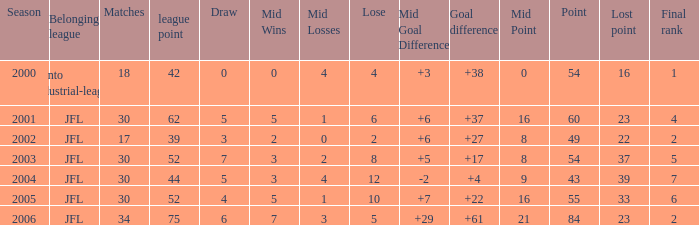Parse the full table. {'header': ['Season', 'Belonging league', 'Matches', 'league point', 'Draw', 'Mid Wins', 'Mid Losses', 'Lose', 'Mid Goal Difference', 'Goal difference', 'Mid Point', 'Point', 'Lost point', 'Final rank'], 'rows': [['2000', 'Kanto industrial-league', '18', '42', '0', '0', '4', '4', '+3', '+38', '0', '54', '16', '1'], ['2001', 'JFL', '30', '62', '5', '5', '1', '6', '+6', '+37', '16', '60', '23', '4'], ['2002', 'JFL', '17', '39', '3', '2', '0', '2', '+6', '+27', '8', '49', '22', '2'], ['2003', 'JFL', '30', '52', '7', '3', '2', '8', '+5', '+17', '8', '54', '37', '5'], ['2004', 'JFL', '30', '44', '5', '3', '4', '12', '-2', '+4', '9', '43', '39', '7'], ['2005', 'JFL', '30', '52', '4', '5', '1', '10', '+7', '+22', '16', '55', '33', '6'], ['2006', 'JFL', '34', '75', '6', '7', '3', '5', '+29', '+61', '21', '84', '23', '2']]} Tell me the average final rank for loe more than 10 and point less than 43 None. 